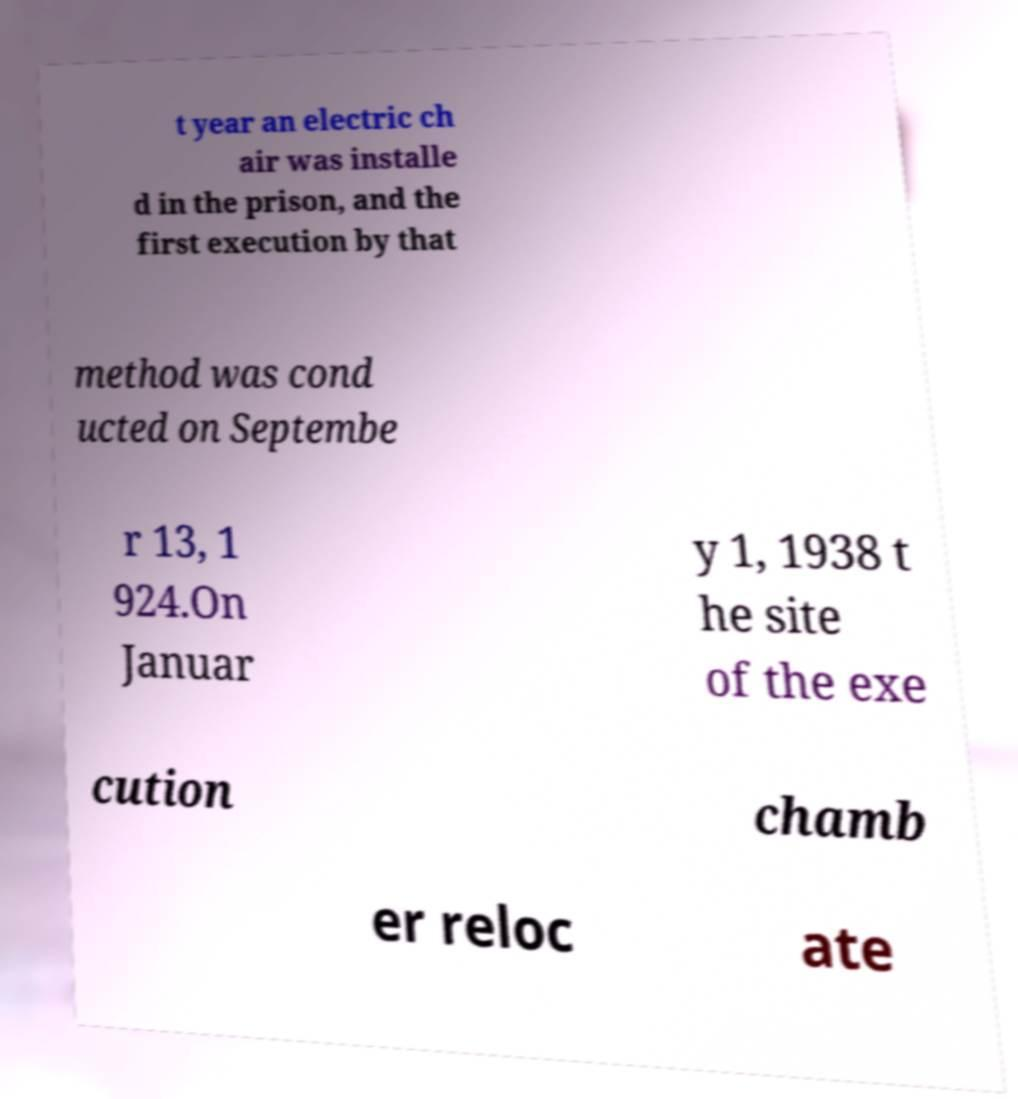Could you extract and type out the text from this image? t year an electric ch air was installe d in the prison, and the first execution by that method was cond ucted on Septembe r 13, 1 924.On Januar y 1, 1938 t he site of the exe cution chamb er reloc ate 